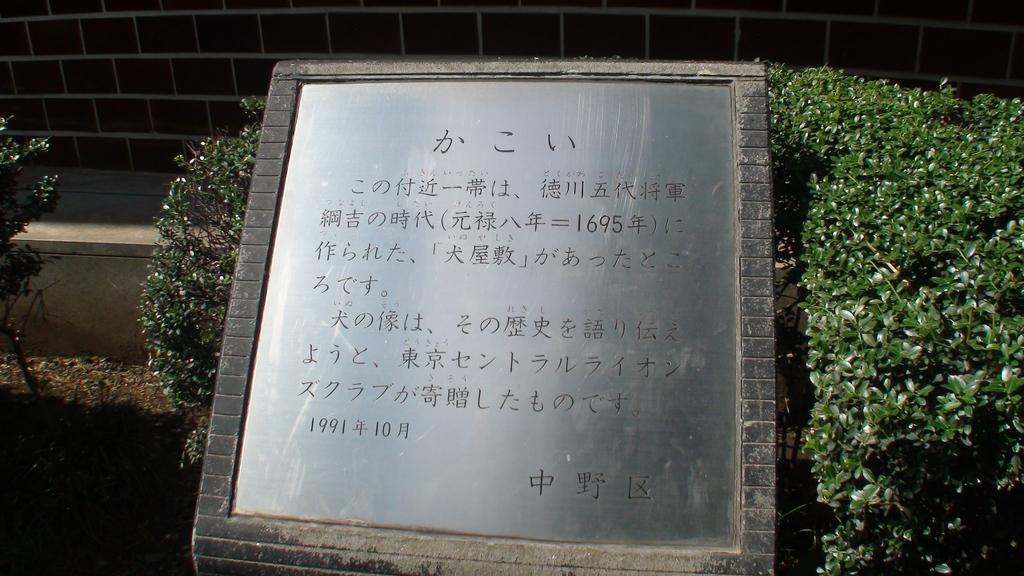What is the main subject in the middle of the picture? There is a memorial in the middle of the picture. What can be seen on either side of the memorial? There are plants on either side of the memorial. What is visible in the background of the picture? There is a wall in the background of the picture. What type of discovery was made at the memorial in the image? There is no indication of a discovery in the image; it simply features a memorial with plants on either side and a wall in the background. Can you see a snake slithering near the memorial in the image? There is no snake present in the image. 